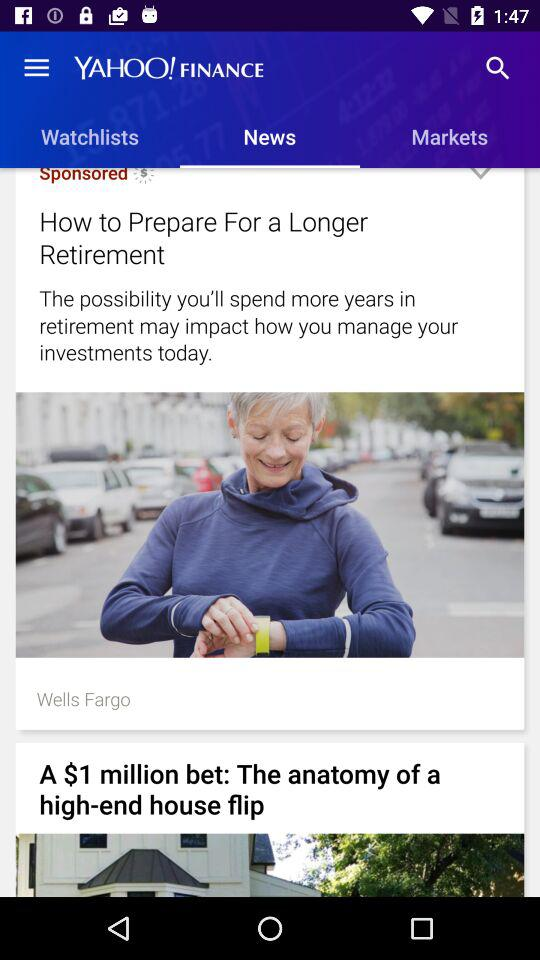What is the name of the application? The application name is "YAHOO! FINANCE". 